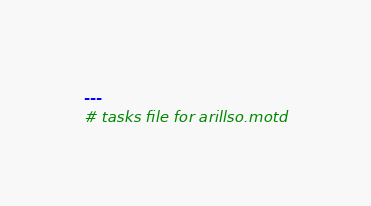<code> <loc_0><loc_0><loc_500><loc_500><_YAML_>---
# tasks file for arillso.motd
</code> 